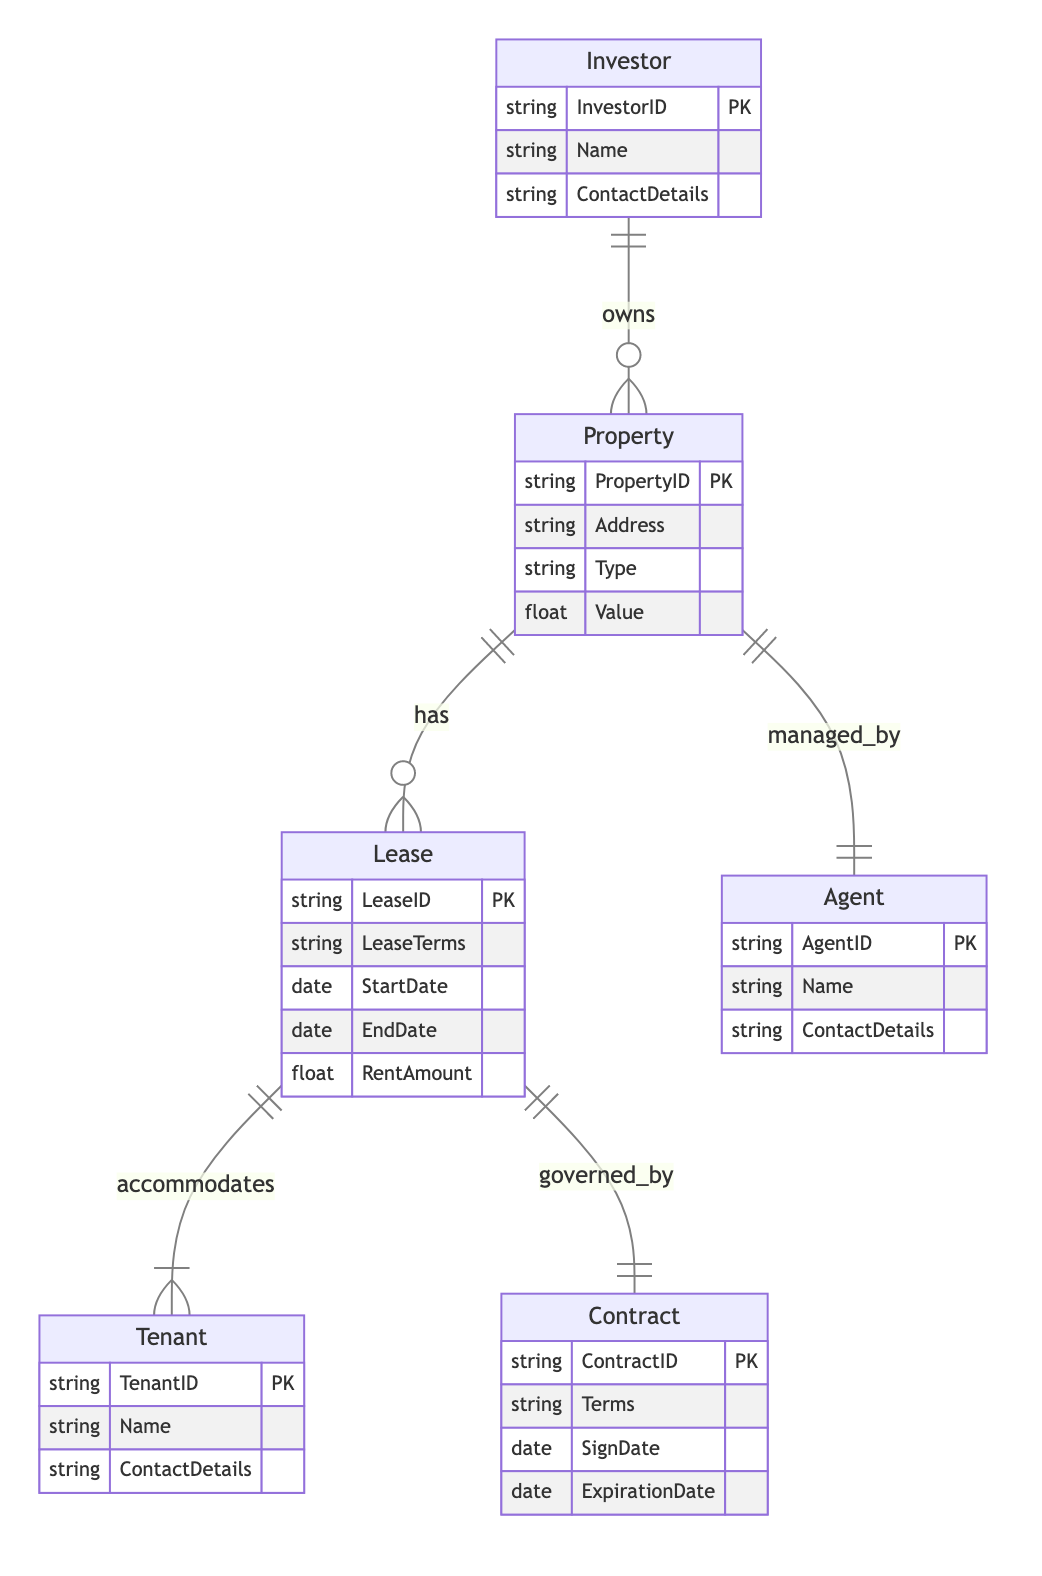What entities are present in this diagram? The diagram depicts six entities: Investor, Property, Agent, Lease, Tenant, and Contract.
Answer: Investor, Property, Agent, Lease, Tenant, Contract How many attributes does the Property entity have? The Property entity has four attributes: PropertyID, Address, Type, and Value.
Answer: Four What relationship exists between Investor and Property? The Investor owns the Property, depicted by the "owns" relationship.
Answer: owns Which entity is linked to Lease through a governing relationship? The Lease is governed by the Contract, shown by the "governed_by" relationship in the diagram.
Answer: Contract How many relationships are associated with the Property entity? The Property entity has three relationships: it is owned by Investor, managed by Agent, and leased to Tenant.
Answer: Three What is the significance of the StartDate attribute in the Lease entity? The StartDate attribute indicates when the Lease agreement begins, which is crucial for lease management.
Answer: Lease agreement start In which relationship does a Tenant participate? The Tenant is involved in the relationship with Lease through accommodating.
Answer: accommodates How many unique roles are defined in the Agent entity? The Agent entity has two unique roles: Name and ContactDetails, indicating their identification attributes.
Answer: Two What is the primary key of the Investor entity? The primary key of the Investor entity is InvestorID, which uniquely identifies each investor.
Answer: InvestorID 